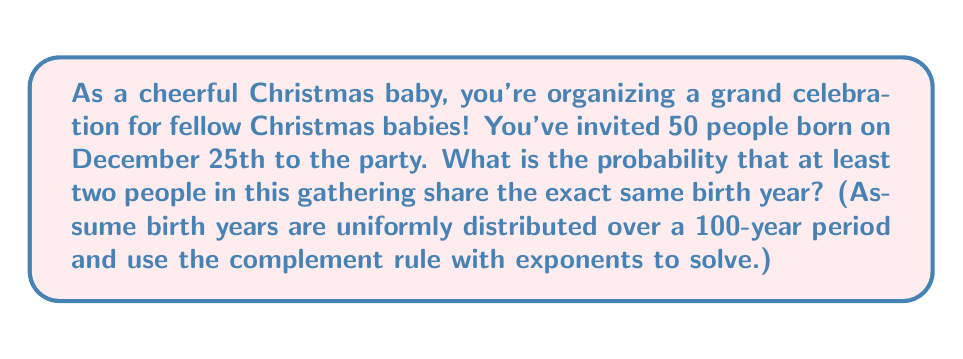Show me your answer to this math problem. Let's approach this step-by-step:

1) First, let's calculate the probability of all 50 people having different birth years:

   $P(\text{all different}) = \frac{100}{100} \cdot \frac{99}{100} \cdot \frac{98}{100} \cdot ... \cdot \frac{51}{100}$

2) This can be written as:

   $P(\text{all different}) = \frac{100!}{(100-50)! \cdot 100^{50}}$

3) Using the complement rule, the probability of at least two people sharing a birth year is:

   $P(\text{at least one match}) = 1 - P(\text{all different})$

4) Now, let's simplify using exponents:

   $P(\text{all different}) = \frac{100!}{50! \cdot 100^{50}}$

5) This can be rewritten as:

   $P(\text{all different}) = \frac{100 \cdot 99 \cdot 98 \cdot ... \cdot 51}{100^{50}}$

6) Which simplifies to:

   $P(\text{all different}) = (1 \cdot 0.99 \cdot 0.98 \cdot ... \cdot 0.51)$

7) This is equivalent to:

   $P(\text{all different}) = \prod_{i=0}^{49} (1 - \frac{i}{100})$

8) Using a calculator or computer, we can compute this value:

   $P(\text{all different}) \approx 0.0354$

9) Therefore, the probability of at least one match is:

   $P(\text{at least one match}) = 1 - 0.0354 \approx 0.9646$
Answer: The probability that at least two people in the gathering of 50 Christmas babies share the same birth year is approximately 0.9646 or 96.46%. 